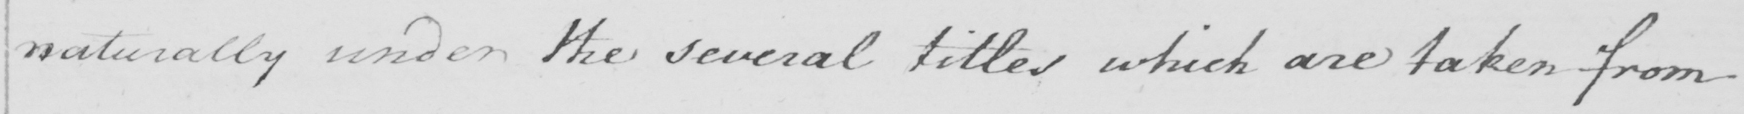Transcribe the text shown in this historical manuscript line. naturally under the several titles which are taken from 